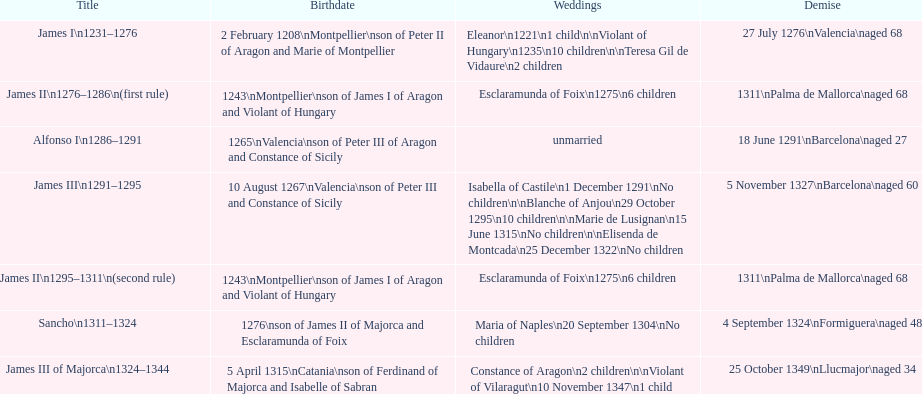Which monarch is listed first? James I 1231-1276. 